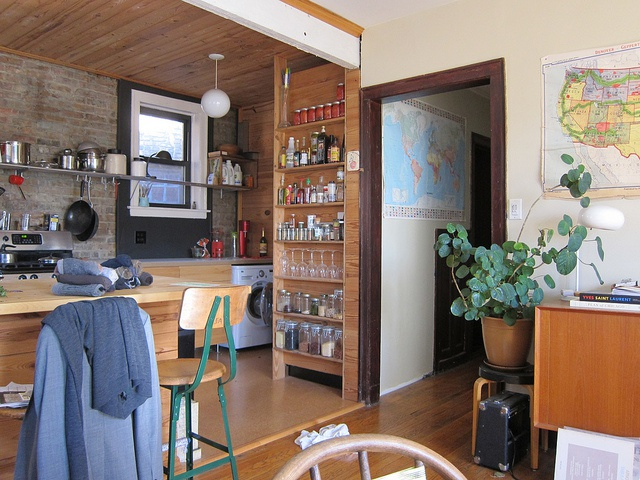Describe the objects in this image and their specific colors. I can see chair in gray and darkgray tones, chair in gray, lightgray, black, and teal tones, potted plant in gray, teal, and black tones, dining table in gray, tan, and darkgray tones, and chair in gray, lightgray, tan, and brown tones in this image. 